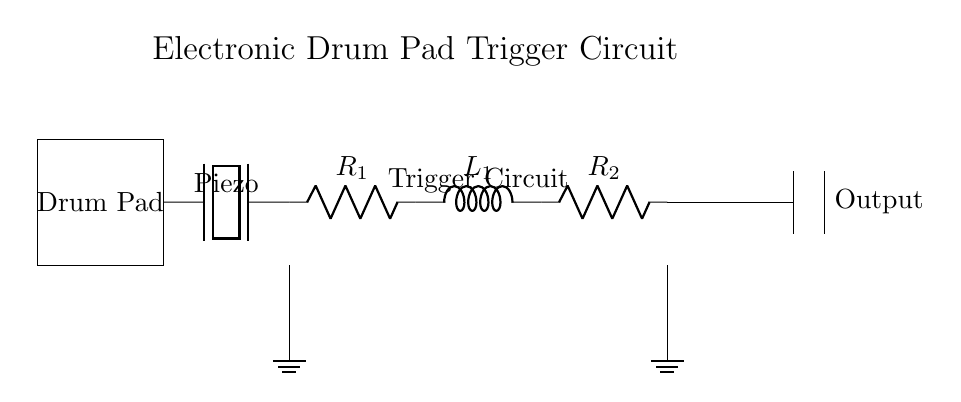What is the first component in the circuit? The first component in the circuit is the drum pad, which is represented as a rectangle on the left side of the diagram.
Answer: Drum Pad What type of component is connected after the drum pad? After the drum pad, a piezoelectric element is connected, which converts mechanical energy from the drum pad into electrical energy.
Answer: Piezoelectric What is the value of the first resistor labeled in the circuit? The first resistor is labeled as R1; however, the actual resistance value is not specified in the diagram, only the label is given.
Answer: R1 What happens when the drum pad is struck? When the drum pad is struck, the piezoelectric element generates a voltage, which causes current to flow through the connected components in the circuit, starting with R1.
Answer: Current flows How are the components R1 and L1 connected in the circuit? R1 and L1 are connected in series, meaning the current that flows through R1 also flows through L1 without any branching at that connection.
Answer: Series What do the resistors and inductor in this circuit work together to form? The resistors and inductor work together to form a trigger circuit, responsible for controlling the signal generated by the piezoelectric element and ensuring it produces the desired output.
Answer: Trigger Circuit In which configuration are the two resistors connected? The two resistors R1 and R2 are connected in series with the inductor L1 between them, creating a sequential path for the current flow through those components.
Answer: Series 